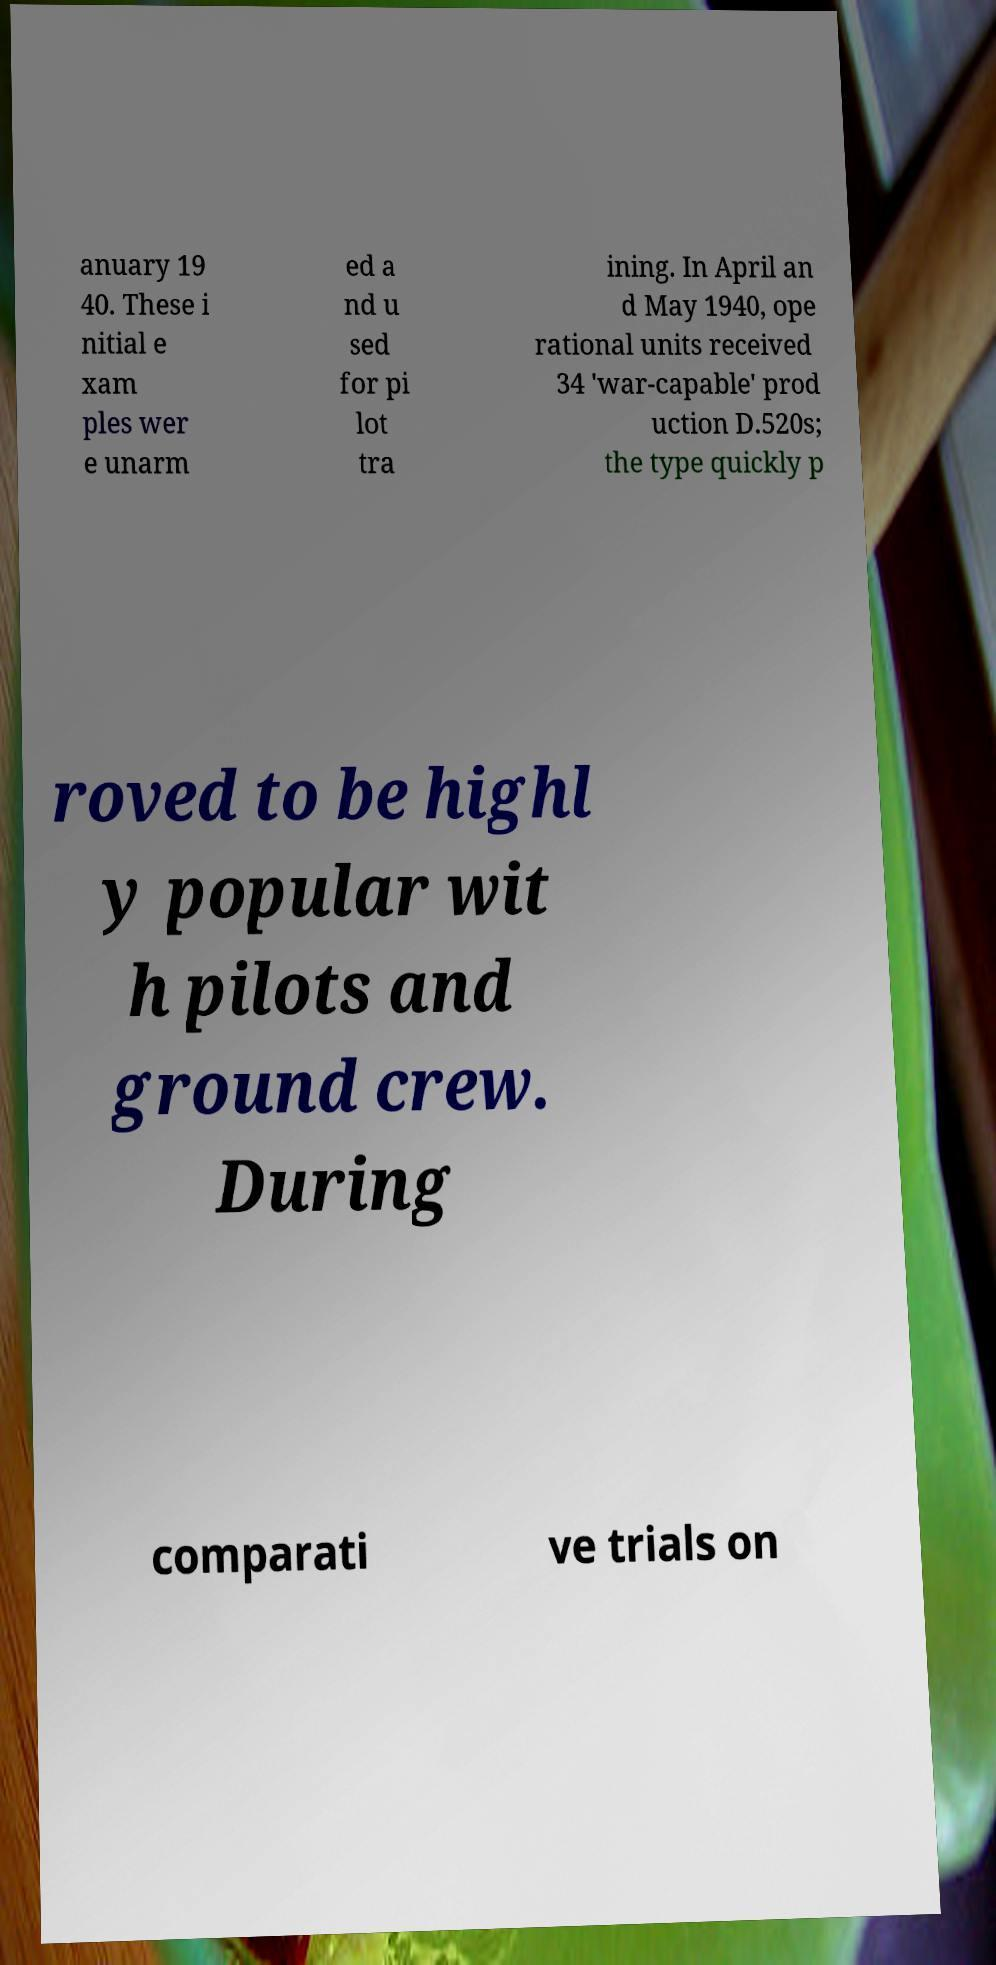Please read and relay the text visible in this image. What does it say? anuary 19 40. These i nitial e xam ples wer e unarm ed a nd u sed for pi lot tra ining. In April an d May 1940, ope rational units received 34 'war-capable' prod uction D.520s; the type quickly p roved to be highl y popular wit h pilots and ground crew. During comparati ve trials on 